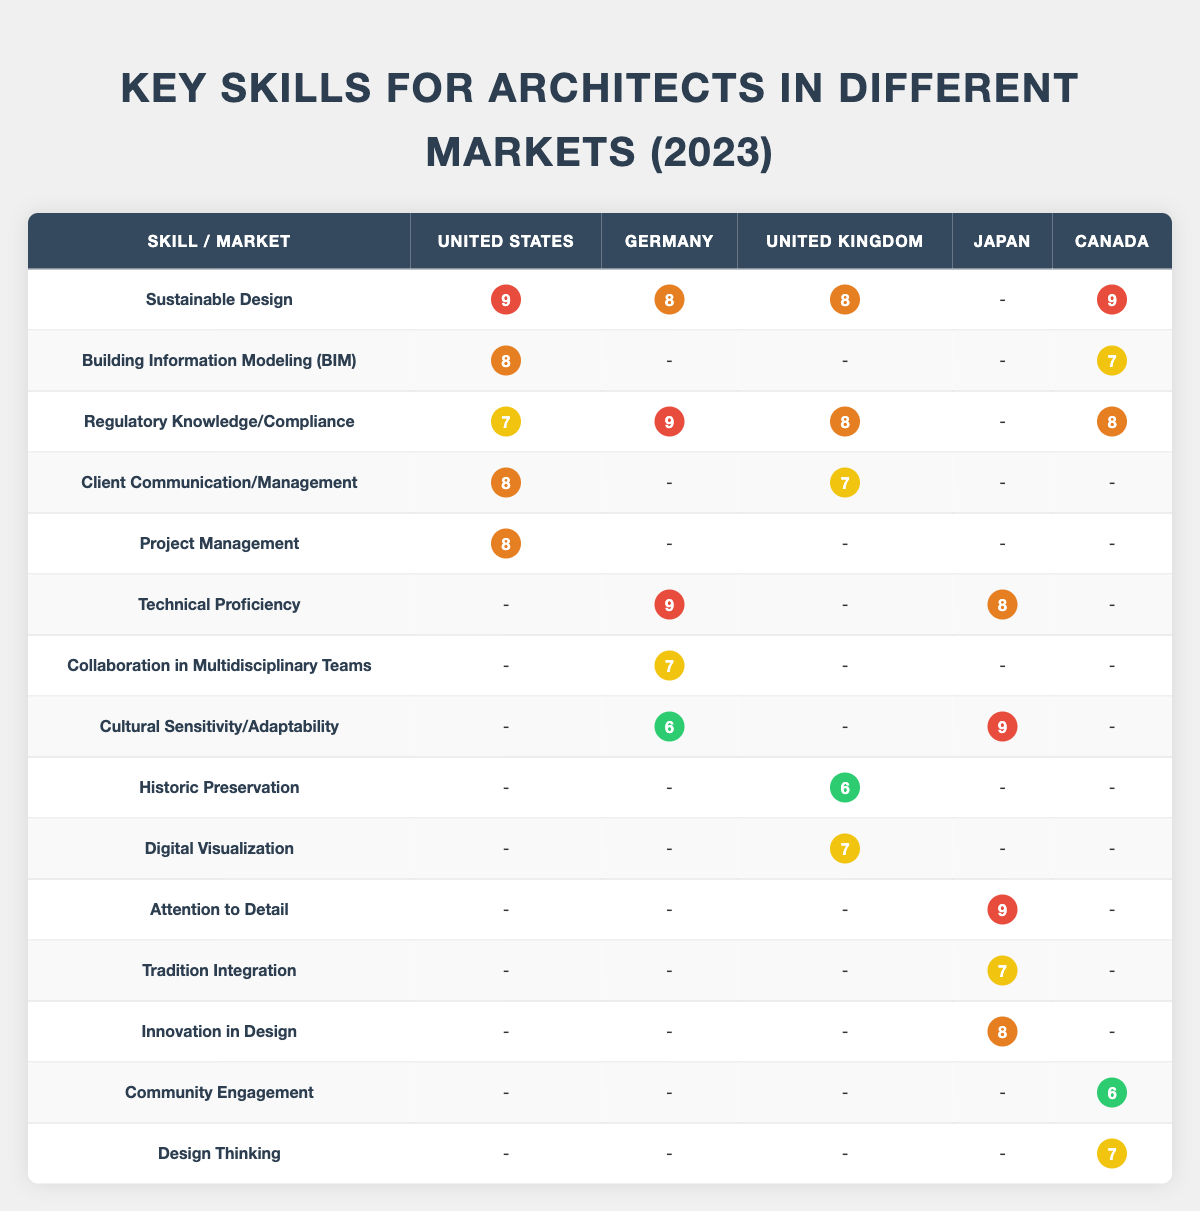What is the highest importance level for sustainable design across the markets? Reviewing the table, the importance levels for sustainable design are: United States (9), Germany (8), United Kingdom (8), Japan (-), and Canada (9). The highest value is 9, found in both the United States and Canada.
Answer: 9 Which market requires technical proficiency as the most important skill? Looking at the table, technical proficiency is rated as the most important skill only in Germany, where its importance level is 9.
Answer: Germany What is the average importance level of client communication across the listed markets? The importance levels for client communication are: United States (8), Germany (-), United Kingdom (7), Japan (-), Canada (-). We will take the sum of the existing values (8 + 7 = 15) and divide by 2 (the number of markets with a score), giving us an average of 7.5.
Answer: 7.5 Is cultural sensitivity considered important in the United Kingdom? Checking the table, the importance of cultural sensitivity in the United Kingdom shows no entry, indicating it is not considered an important skill there.
Answer: No Which skill has the lowest importance level across all markets listed? By examining the table, the skill with the lowest importance rating is community engagement, which has a score of 6 in Canada. There are other skills with scores of 6, but community engagement is the only one that appears in this context.
Answer: Community Engagement How many markets rate innovation in design as equally important to Japan? The table shows that Japan rates innovation in design at an importance level of 8, which does not match any other market's rating; however, Germany and the United Kingdom have an importance level of 8 for various skills, affirming that they share similar importance levels but not specifically for innovation in design. Thus, the total is 0 markets.
Answer: 0 What is the difference in importance level between regulatory knowledge in the United States and Germany? Regulatory knowledge is rated at 7 in the United States and 9 in Germany. We calculate the difference: 9 - 7 = 2.
Answer: 2 Which skills are rated as important (7 or above) in Canada? The skills rated 7 or above in Canada are sustainable architecture (9), regulatory understanding (8), BIM proficiency (7), and design thinking (7). These reflect a good mix of both soft and hard skills, demonstrating a comprehensive approach in that market.
Answer: 4 Skills What is the only skill that is rated as significant (importance level 9) in both the United States and Canada? Both the United States and Canada rate sustainable design as having an importance level of 9, highlighting its critical role in both markets for architects.
Answer: Sustainable Design 